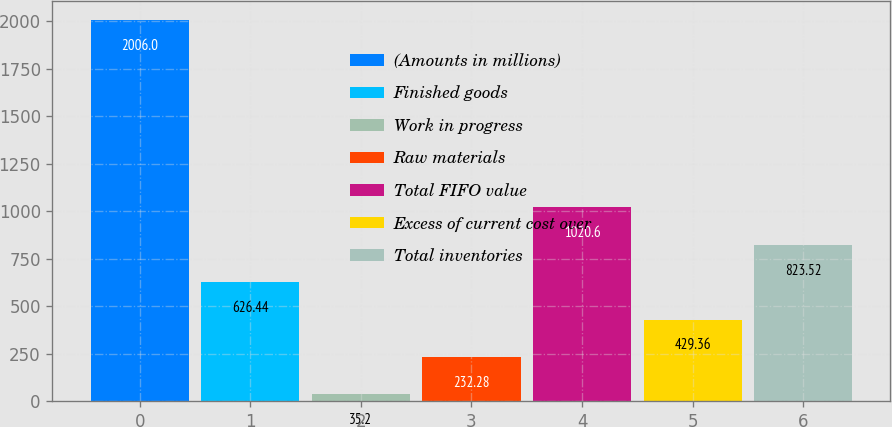<chart> <loc_0><loc_0><loc_500><loc_500><bar_chart><fcel>(Amounts in millions)<fcel>Finished goods<fcel>Work in progress<fcel>Raw materials<fcel>Total FIFO value<fcel>Excess of current cost over<fcel>Total inventories<nl><fcel>2006<fcel>626.44<fcel>35.2<fcel>232.28<fcel>1020.6<fcel>429.36<fcel>823.52<nl></chart> 